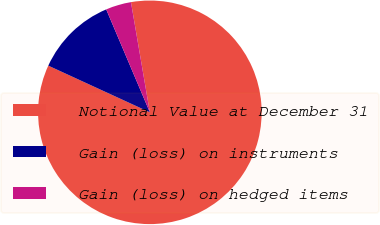<chart> <loc_0><loc_0><loc_500><loc_500><pie_chart><fcel>Notional Value at December 31<fcel>Gain (loss) on instruments<fcel>Gain (loss) on hedged items<nl><fcel>84.56%<fcel>11.76%<fcel>3.68%<nl></chart> 